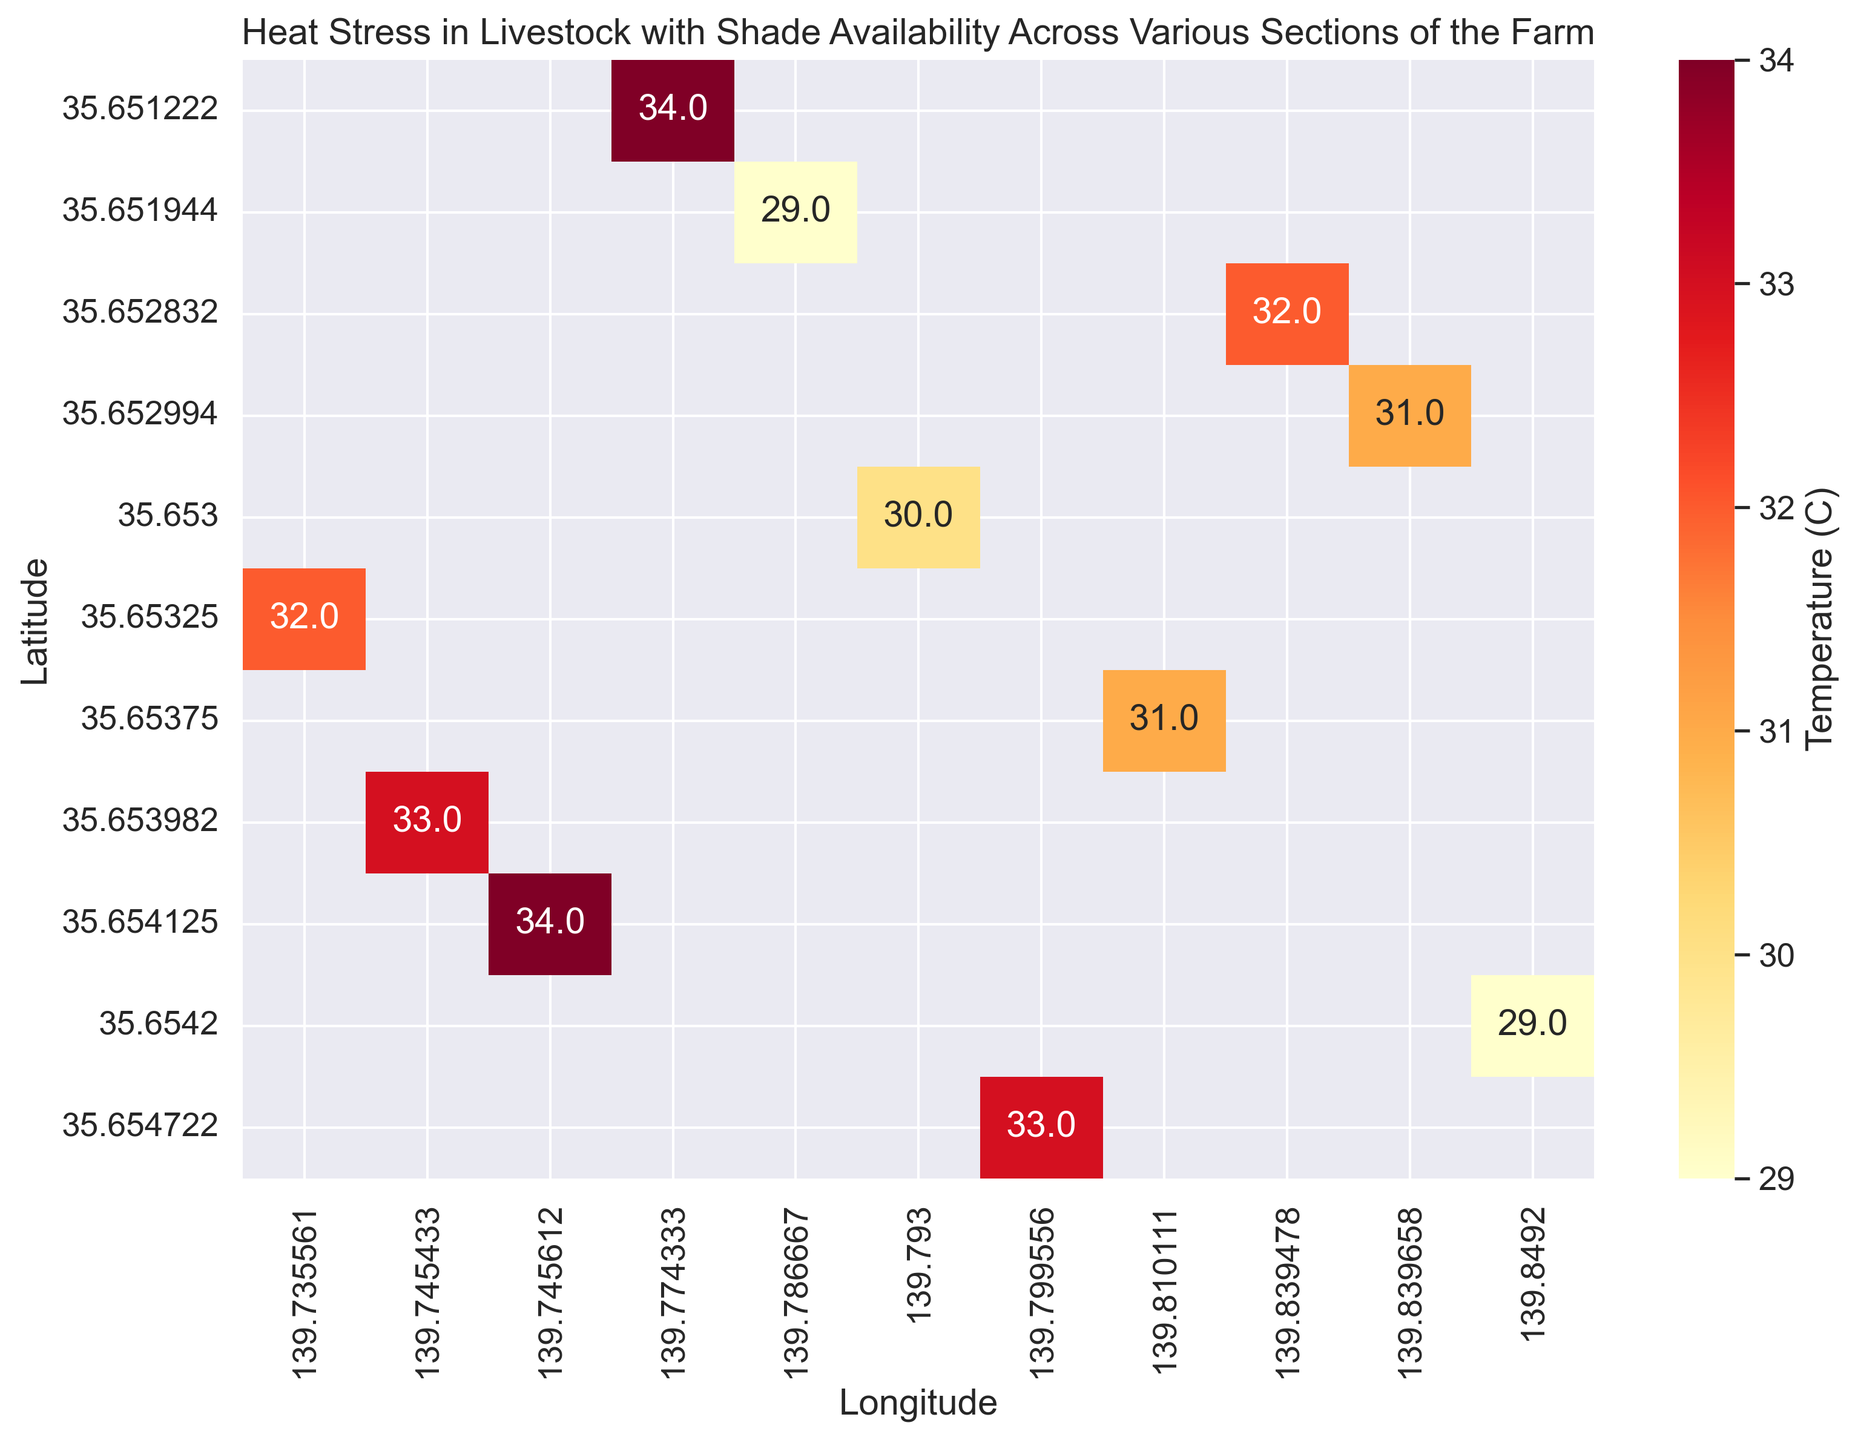Which section of the farm has the highest temperature? By observing the heatmap and checking the numerical values, we identify the plot with the highest temperature.
Answer: South-West and South-Central have the highest temperatures of 34°C Which section has the lowest temperature, and what is it? We look for the area on the heatmap with the smallest numerical value.
Answer: Far-East and Near-South have the lowest temperature of 29°C What is the average temperature across all sections? Add up all the temperature values and divide by the number of sections: (32 + 33 + 31 + 34 + 30 + 29 + 32 + 33 + 29 + 31 + 34)/11.
Answer: The average temperature is approximately 31.3°C Which sections have temperatures higher than the average? Identify sections where the temperature exceeds 31.3°C by comparing each section's value to the average.
Answer: North-West, South-West, Near-North, and South-Central have temperatures higher than the average Do any sections with high shade availability (above 80%) also have high temperatures (above 32°C)? Look for sections with shade availability greater than 80% and temperatures above 32°C.
Answer: Near-North has 85% shade availability with a temperature of 33°C Which section covers the most northeast location on the farm according to the heatmap? Identify the section that is the furthest to the top-right corner on the heatmap.
Answer: North-East is the most northeast section Between North-East and Far-East sections, which one demonstrates better heat stress conditions considering both temperature and shade availability? Compare both temperature and shade availability, finding that lower temperature and higher shade availability indicate better conditions.
Answer: Far-East, because it has a lower temperature (29°C) and higher shade availability (90%) Comparing North-Central and South-Central sections, which one is more likely to experience greater heat stress? Assess both temperature and shade availability for heat stress likelihood. Higher temperature and lower shade contribute to higher stress.
Answer: South-Central, due to higher temperature (34°C) and lower shade availability (60%) What shade availability percentage would you expect in the section with the lowest temperature? Check the shade availability percentage in the sections with the lowest temperatures, which are Far-East and Near-South.
Answer: For Far-East, it is 90%, and for Near-South, it is 65% Are there any sections where both temperature and shade availability are close to the average across the farm? Calculate the average temperature (31.3°C) and shade availability (71.8%), and find sections close to these values.
Answer: North-Central with 31°C temperature and 88% shade availability is closest to average conditions 